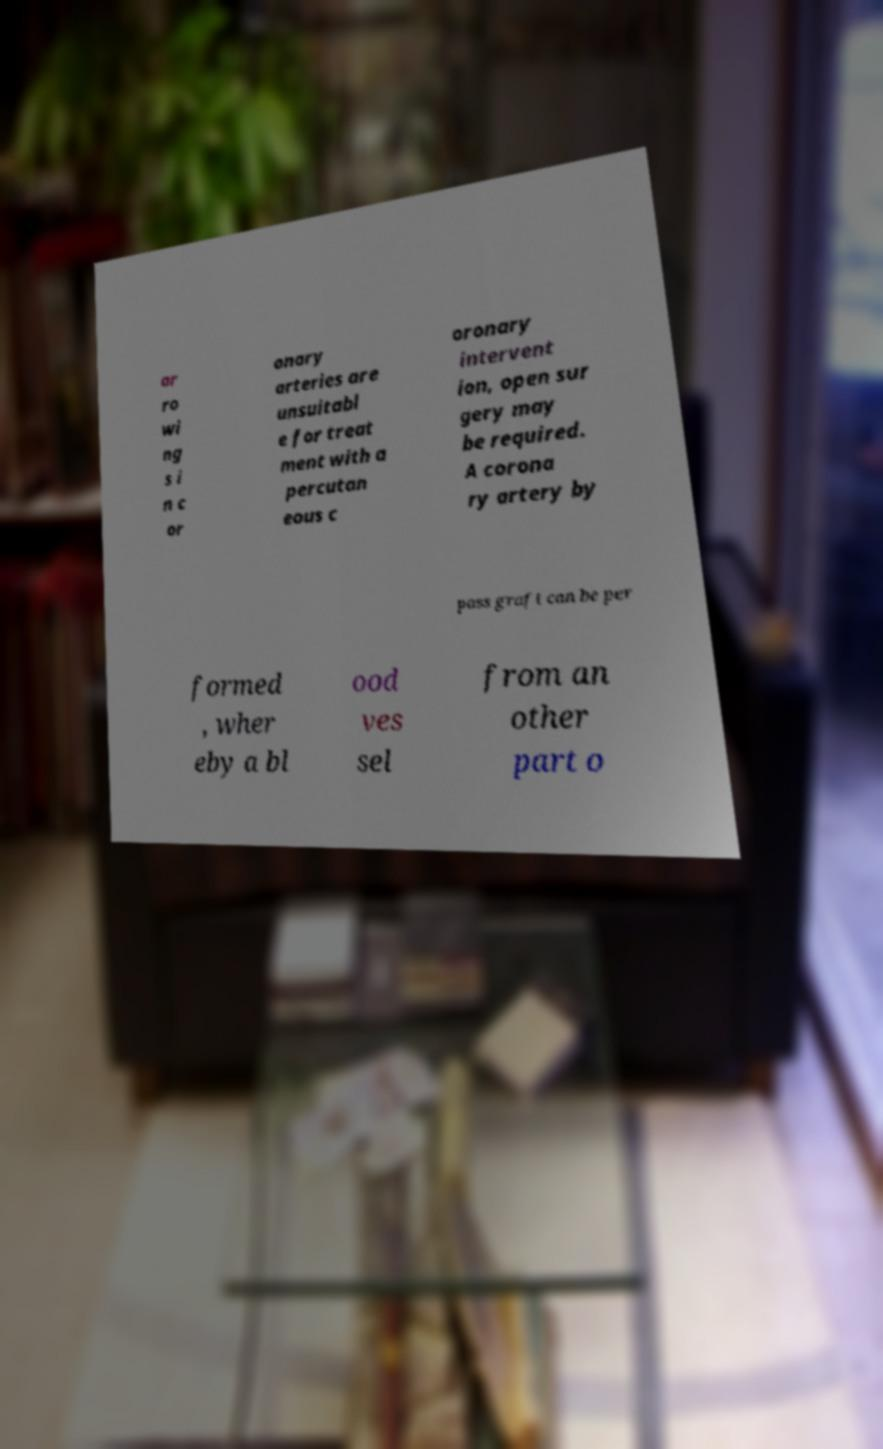What messages or text are displayed in this image? I need them in a readable, typed format. ar ro wi ng s i n c or onary arteries are unsuitabl e for treat ment with a percutan eous c oronary intervent ion, open sur gery may be required. A corona ry artery by pass graft can be per formed , wher eby a bl ood ves sel from an other part o 